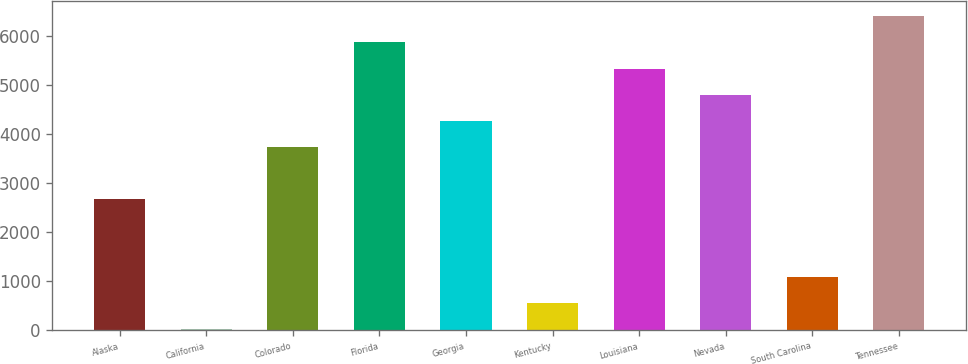Convert chart to OTSL. <chart><loc_0><loc_0><loc_500><loc_500><bar_chart><fcel>Alaska<fcel>California<fcel>Colorado<fcel>Florida<fcel>Georgia<fcel>Kentucky<fcel>Louisiana<fcel>Nevada<fcel>South Carolina<fcel>Tennessee<nl><fcel>2679<fcel>22<fcel>3741.8<fcel>5867.4<fcel>4273.2<fcel>553.4<fcel>5336<fcel>4804.6<fcel>1084.8<fcel>6398.8<nl></chart> 